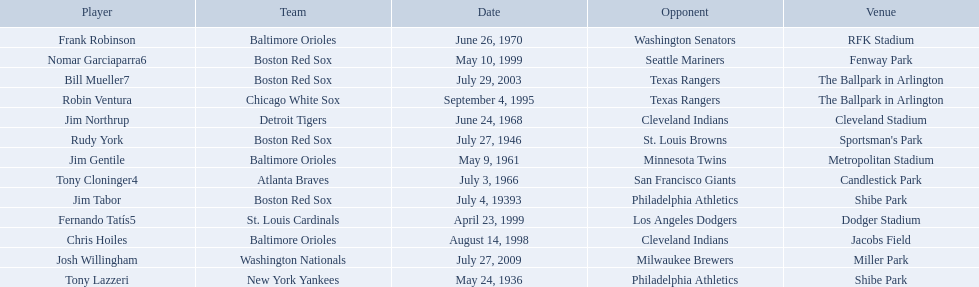Can you parse all the data within this table? {'header': ['Player', 'Team', 'Date', 'Opponent', 'Venue'], 'rows': [['Frank Robinson', 'Baltimore Orioles', 'June 26, 1970', 'Washington Senators', 'RFK Stadium'], ['Nomar Garciaparra6', 'Boston Red Sox', 'May 10, 1999', 'Seattle Mariners', 'Fenway Park'], ['Bill Mueller7', 'Boston Red Sox', 'July 29, 2003', 'Texas Rangers', 'The Ballpark in Arlington'], ['Robin Ventura', 'Chicago White Sox', 'September 4, 1995', 'Texas Rangers', 'The Ballpark in Arlington'], ['Jim Northrup', 'Detroit Tigers', 'June 24, 1968', 'Cleveland Indians', 'Cleveland Stadium'], ['Rudy York', 'Boston Red Sox', 'July 27, 1946', 'St. Louis Browns', "Sportsman's Park"], ['Jim Gentile', 'Baltimore Orioles', 'May 9, 1961', 'Minnesota Twins', 'Metropolitan Stadium'], ['Tony Cloninger4', 'Atlanta Braves', 'July 3, 1966', 'San Francisco Giants', 'Candlestick Park'], ['Jim Tabor', 'Boston Red Sox', 'July 4, 19393', 'Philadelphia Athletics', 'Shibe Park'], ['Fernando Tatís5', 'St. Louis Cardinals', 'April 23, 1999', 'Los Angeles Dodgers', 'Dodger Stadium'], ['Chris Hoiles', 'Baltimore Orioles', 'August 14, 1998', 'Cleveland Indians', 'Jacobs Field'], ['Josh Willingham', 'Washington Nationals', 'July 27, 2009', 'Milwaukee Brewers', 'Miller Park'], ['Tony Lazzeri', 'New York Yankees', 'May 24, 1936', 'Philadelphia Athletics', 'Shibe Park']]} What are the dates? May 24, 1936, July 4, 19393, July 27, 1946, May 9, 1961, July 3, 1966, June 24, 1968, June 26, 1970, September 4, 1995, August 14, 1998, April 23, 1999, May 10, 1999, July 29, 2003, July 27, 2009. Which date is in 1936? May 24, 1936. What player is listed for this date? Tony Lazzeri. What venue did detroit play cleveland in? Cleveland Stadium. Who was the player? Jim Northrup. What date did they play? June 24, 1968. 